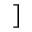<formula> <loc_0><loc_0><loc_500><loc_500>]</formula> 